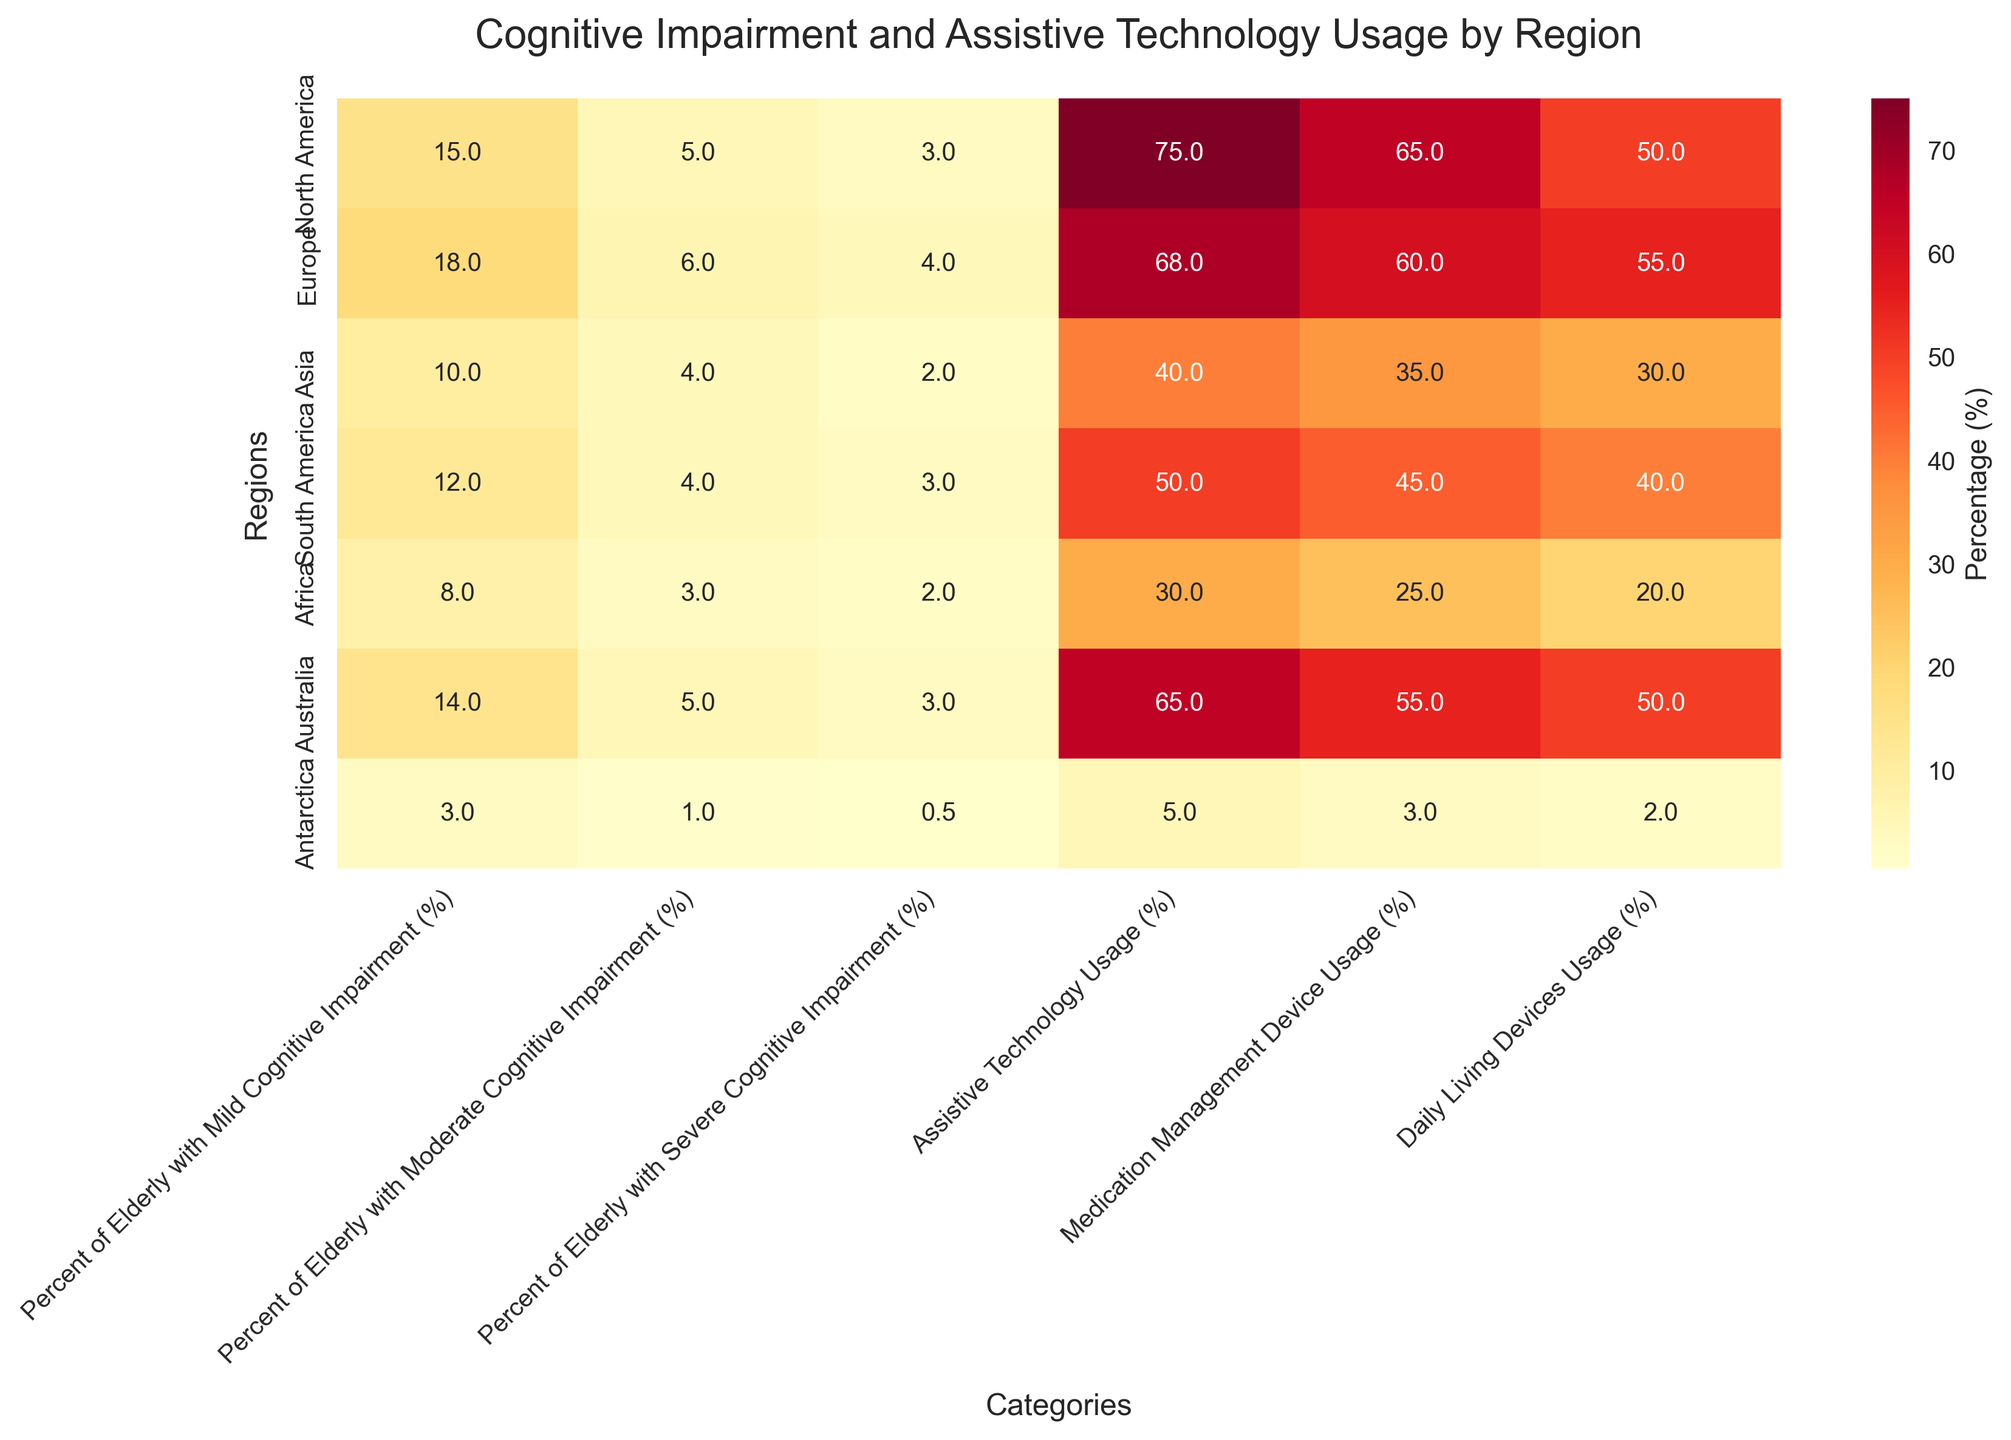What is the title of the heatmap? The title is usually located at the top of the plot. In this case, it reads "Cognitive Impairment and Assistive Technology Usage by Region".
Answer: Cognitive Impairment and Assistive Technology Usage by Region Which region has the highest percentage of elderly with mild cognitive impairment? To find the region with the highest value in the column "Percent of Elderly with Mild Cognitive Impairment (%)", we can look for the largest number in this column. Europe shows the highest percentage, which is 18%.
Answer: Europe What is the percentage of assistive technology usage in South America? Locate the row for South America and then find the value under the column "Assistive Technology Usage (%)". The value is 50%.
Answer: 50% Compare the percentage of elderly with moderate cognitive impairment in North America and Australia. Which region has a higher percentage? We need to compare values in the "Percent of Elderly with Moderate Cognitive Impairment (%)" column for North America and Australia. Both have a percentage of 5%, so they are equal.
Answer: Equal What is the average percentage of elderly with severe cognitive impairment across all regions? Sum up all the percentages of elderly with severe cognitive impairment from each region and divide by the number of regions. (3 + 4 + 2 + 3 + 2 + 3 + 0.5) / 7 = 17.5 / 7 = 2.5%
Answer: 2.5% How does the usage of medication management devices in Asia compare to that in North America? Find the values in the "Medication Management Device Usage (%)" column for Asia and North America. Asia has 35%, while North America has 65%. So, North America has a higher usage.
Answer: North America has higher usage Which region has the lowest percentage of elderly with severe cognitive impairment? Look for the smallest number in the "Percent of Elderly with Severe Cognitive Impairment (%)" column. Antarctica has the lowest percentage with 0.5%.
Answer: Antarctica Is the usage of daily living devices in Europe greater than or equal to 50%? Check the value in the "Daily Living Devices Usage (%)" column for Europe. The value is 55%, which is greater than 50%.
Answer: Greater than 50% What is the difference in the percentage of assistive technology usage between Australia and Africa? Subtract the percentage of Africa from Australia's percentage in the "Assistive Technology Usage (%)" column. 65% - 30% = 35%.
Answer: 35% Which two regions have the closest percentage of elderly with mild cognitive impairment? Compare the values in the "Percent of Elderly with Mild Cognitive Impairment (%)" column and find the two regions with the smallest difference. North America (15%) and Australia (14%) have only a 1% difference.
Answer: North America and Australia 